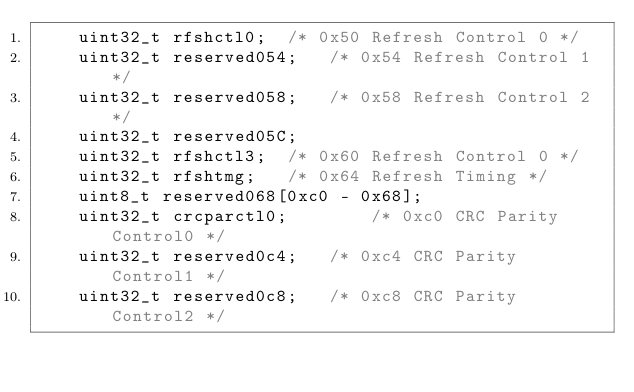<code> <loc_0><loc_0><loc_500><loc_500><_C_>	uint32_t rfshctl0;	/* 0x50 Refresh Control 0 */
	uint32_t reserved054;	/* 0x54 Refresh Control 1 */
	uint32_t reserved058;	/* 0x58 Refresh Control 2 */
	uint32_t reserved05C;
	uint32_t rfshctl3;	/* 0x60 Refresh Control 0 */
	uint32_t rfshtmg;	/* 0x64 Refresh Timing */
	uint8_t reserved068[0xc0 - 0x68];
	uint32_t crcparctl0;		/* 0xc0 CRC Parity Control0 */
	uint32_t reserved0c4;	/* 0xc4 CRC Parity Control1 */
	uint32_t reserved0c8;	/* 0xc8 CRC Parity Control2 */</code> 